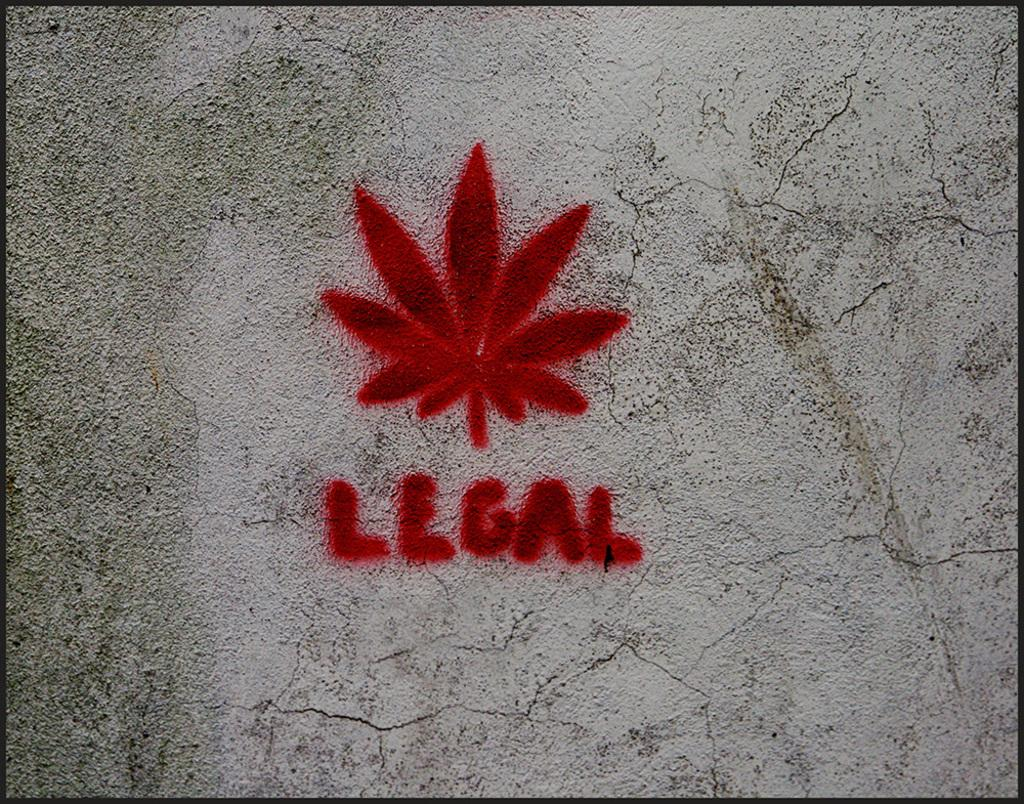What is the main feature of the image? There is a wall in the image. What can be seen on the wall? A leaf is painted on the wall in red color, and there is text written on the wall. What is the fifth thing written on the wall? There is no information about the number of things written on the wall, so it is impossible to determine the fifth thing. 